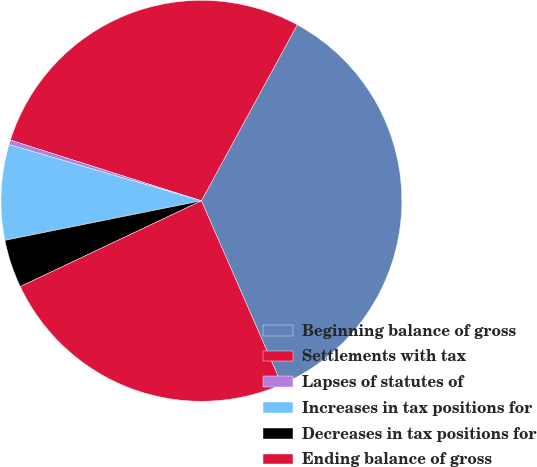Convert chart to OTSL. <chart><loc_0><loc_0><loc_500><loc_500><pie_chart><fcel>Beginning balance of gross<fcel>Settlements with tax<fcel>Lapses of statutes of<fcel>Increases in tax positions for<fcel>Decreases in tax positions for<fcel>Ending balance of gross<nl><fcel>35.51%<fcel>28.04%<fcel>0.37%<fcel>7.69%<fcel>3.88%<fcel>24.52%<nl></chart> 